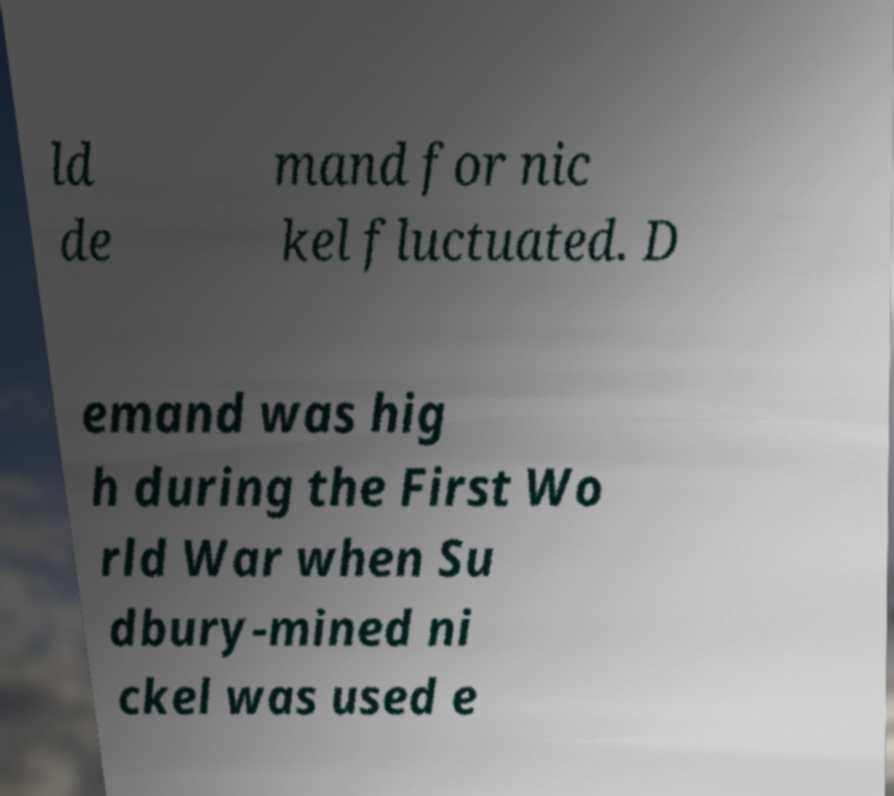Can you accurately transcribe the text from the provided image for me? ld de mand for nic kel fluctuated. D emand was hig h during the First Wo rld War when Su dbury-mined ni ckel was used e 